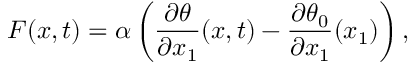<formula> <loc_0><loc_0><loc_500><loc_500>F ( x , t ) = \alpha \left ( \frac { \partial \theta } { \partial x _ { 1 } } ( x , t ) - \frac { \partial \theta _ { 0 } } { \partial x _ { 1 } } ( x _ { 1 } ) \right ) ,</formula> 